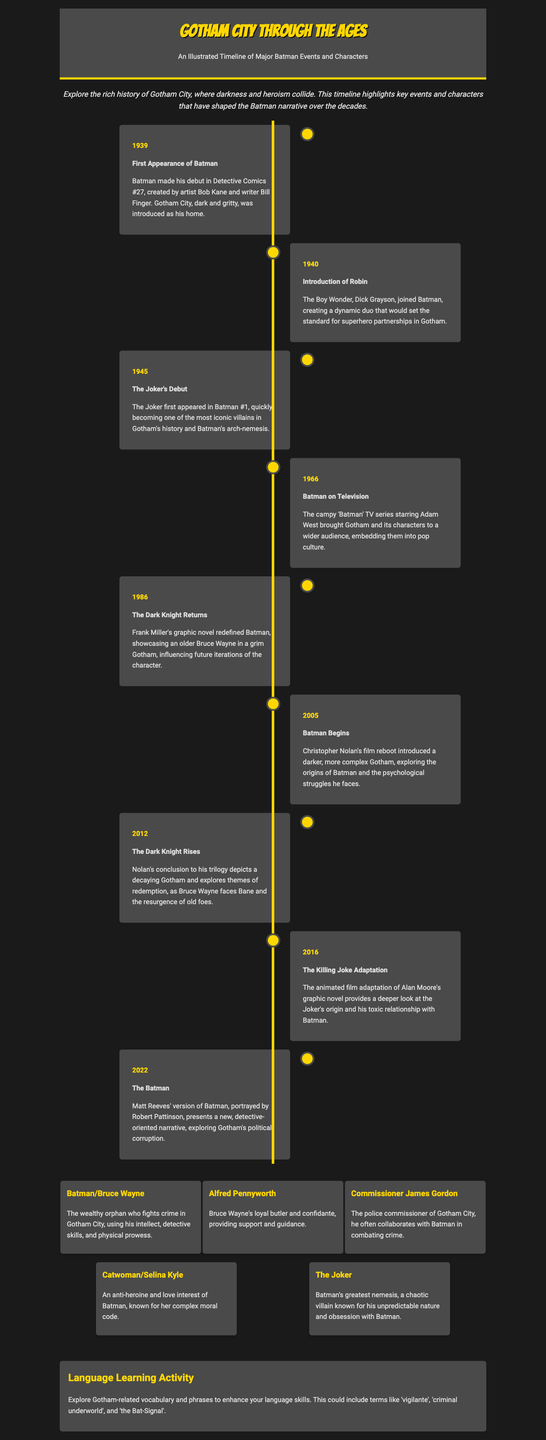What year did Batman first appear? Batman made his debut in Detective Comics #27 in 1939.
Answer: 1939 Who joined Batman in 1940? Dick Grayson, also known as Robin, joined Batman in 1940.
Answer: Robin In what year did The Joker first appear? The Joker debuted in Batman #1, which was published in 1945.
Answer: 1945 What significant event occurred in Gotham City in 1986? Frank Miller's graphic novel "The Dark Knight Returns" redefined Batman in 1986.
Answer: The Dark Knight Returns Who directed the film "Batman Begins"? Christopher Nolan directed "Batman Begins", released in 2005.
Answer: Christopher Nolan What is the main theme of "The Dark Knight Rises"? It explores themes of redemption in the context of a decaying Gotham.
Answer: Redemption What character is known as Batman's greatest nemesis? The Joker is recognized as Batman's greatest nemesis.
Answer: The Joker Which character provides support and guidance to Bruce Wayne? Alfred Pennyworth is Bruce Wayne's loyal butler providing support.
Answer: Alfred Pennyworth What type of activity is suggested in the language learning section? The language learning section suggests exploring Gotham-related vocabulary and phrases.
Answer: Vocabulary and phrases 